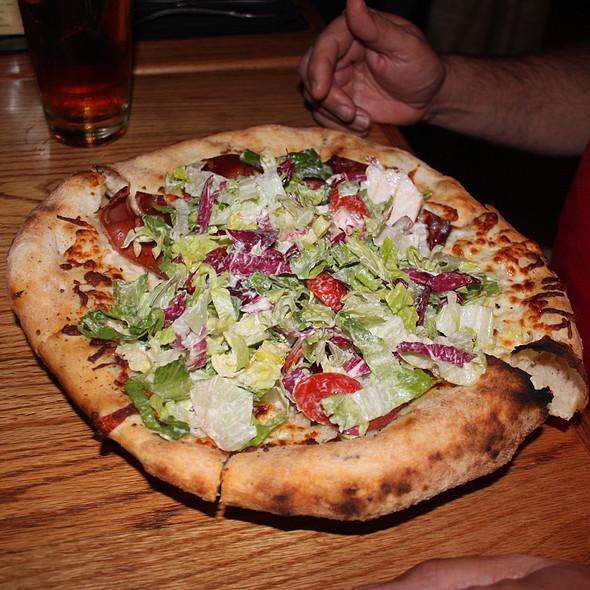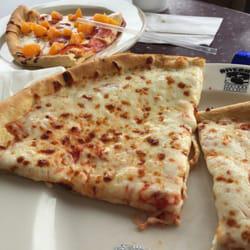The first image is the image on the left, the second image is the image on the right. For the images shown, is this caption "The left image shows a pizza that is sliced but no slices are missing, and the right image shows a plate with some slices on it." true? Answer yes or no. Yes. The first image is the image on the left, the second image is the image on the right. Analyze the images presented: Is the assertion "At least one straw is visible in the right image." valid? Answer yes or no. Yes. 